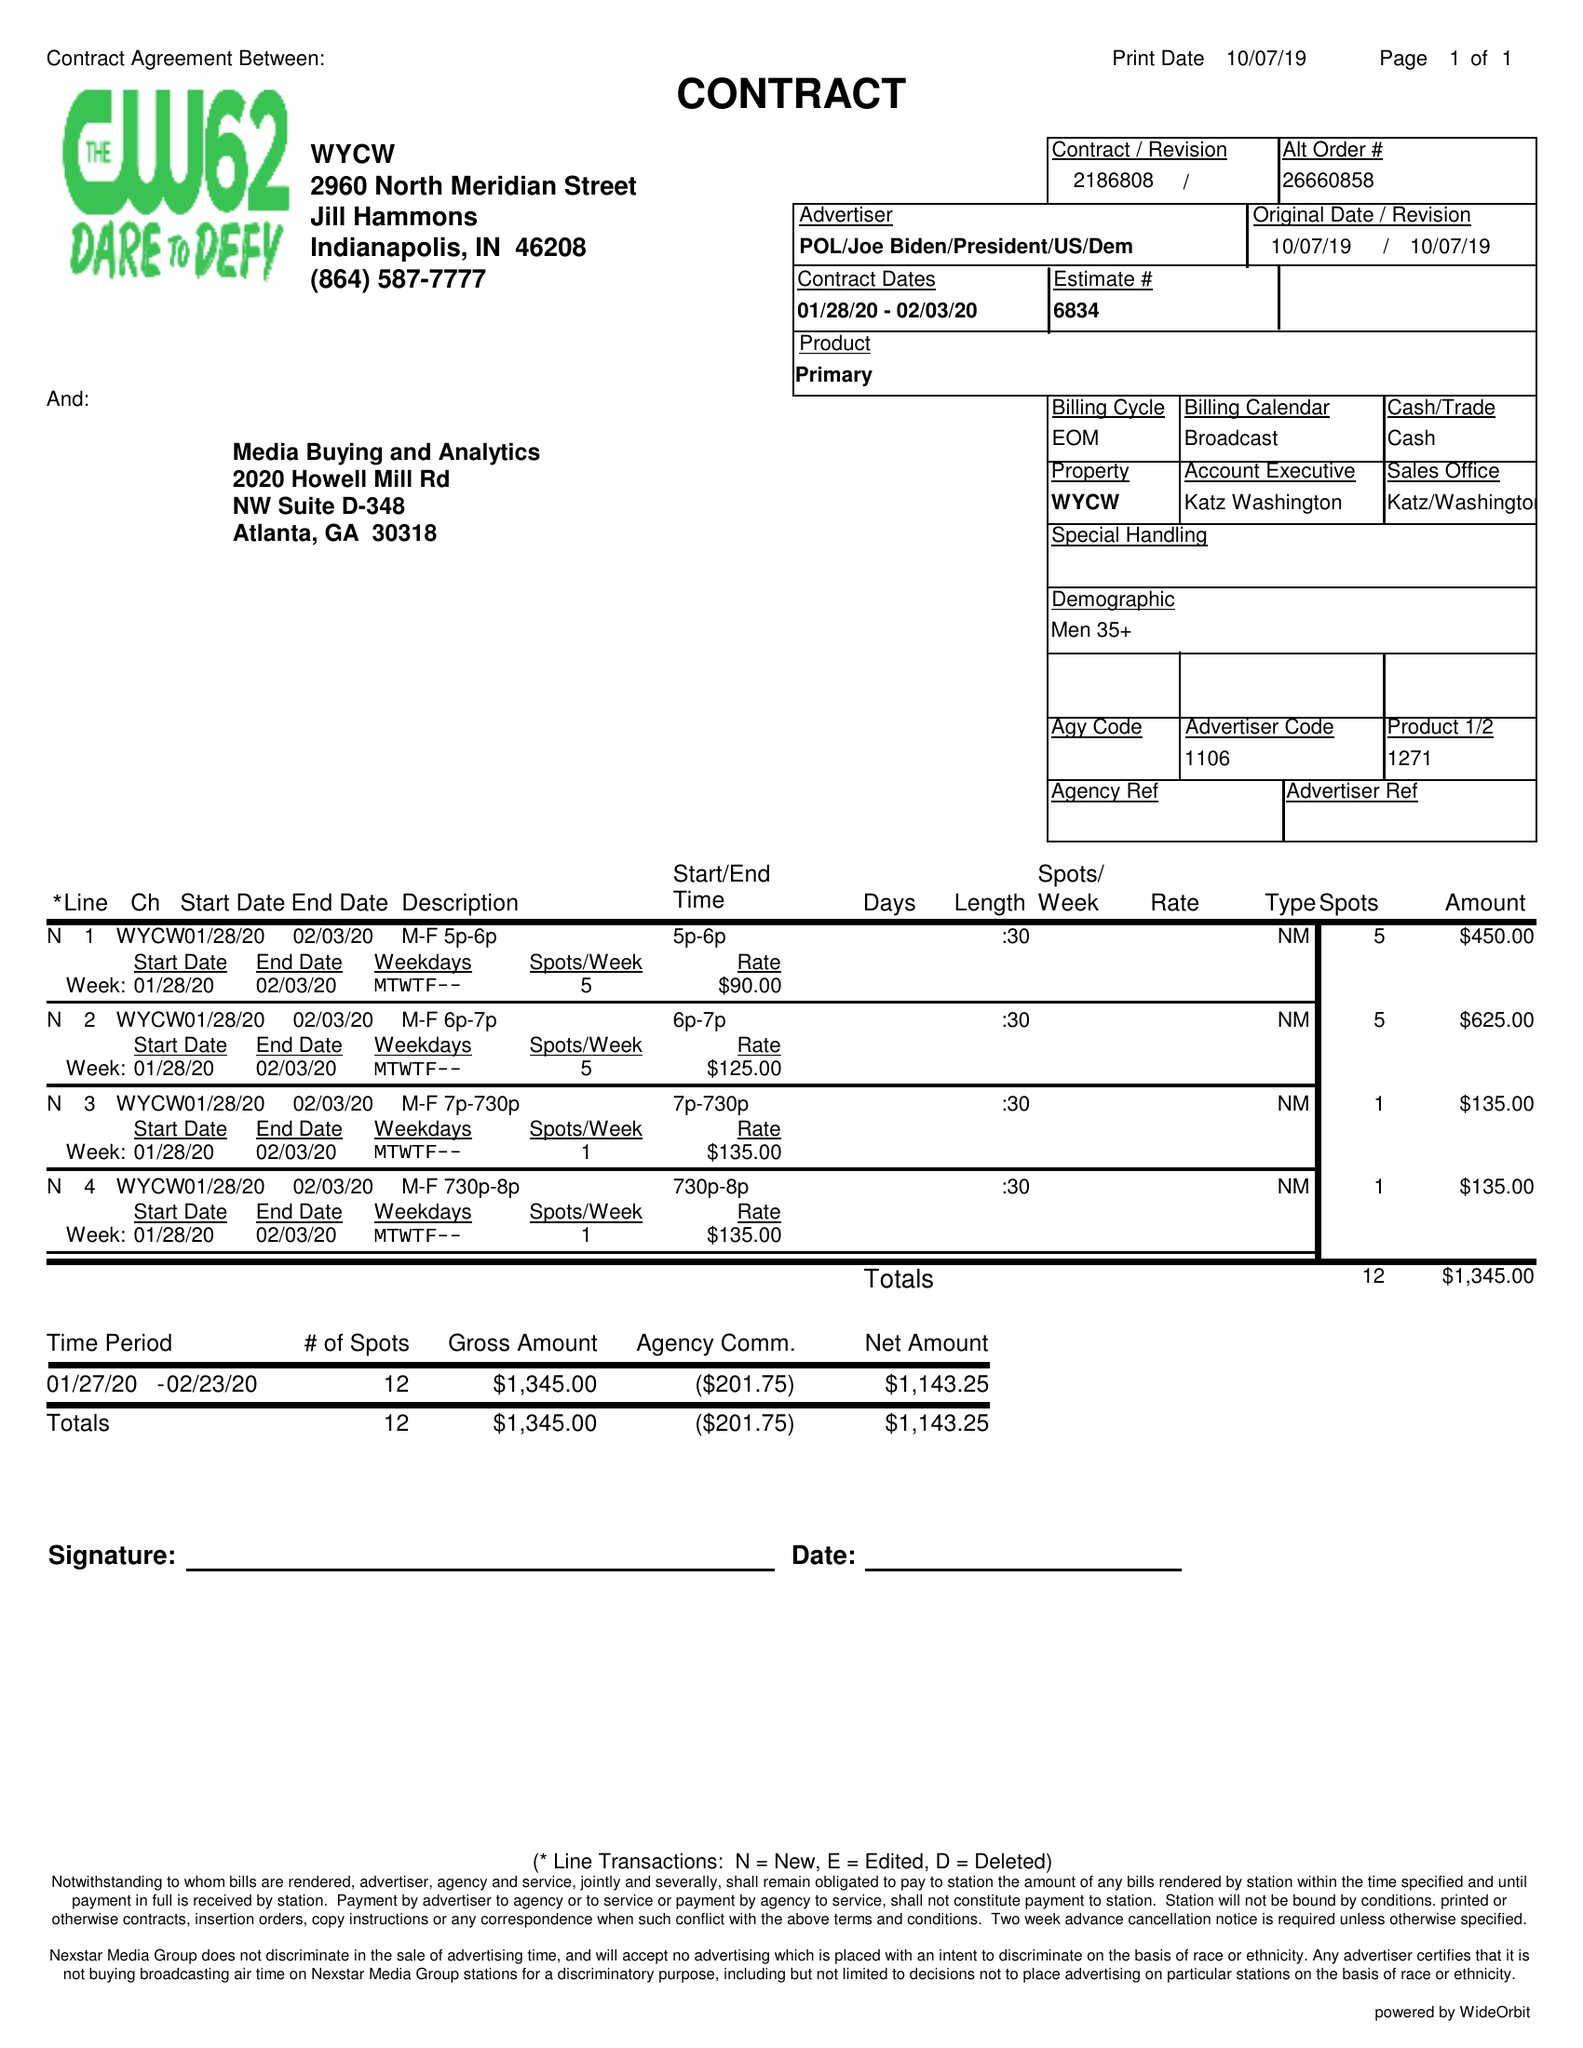What is the value for the flight_from?
Answer the question using a single word or phrase. 01/28/20 